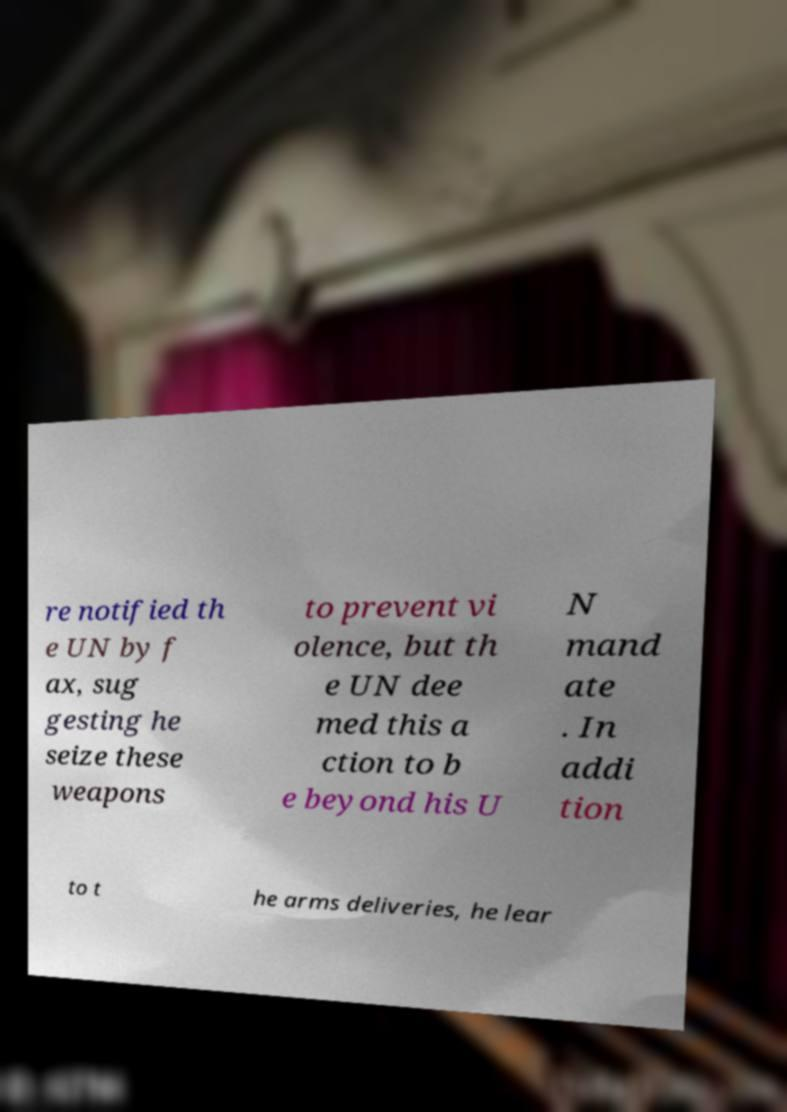Please read and relay the text visible in this image. What does it say? re notified th e UN by f ax, sug gesting he seize these weapons to prevent vi olence, but th e UN dee med this a ction to b e beyond his U N mand ate . In addi tion to t he arms deliveries, he lear 